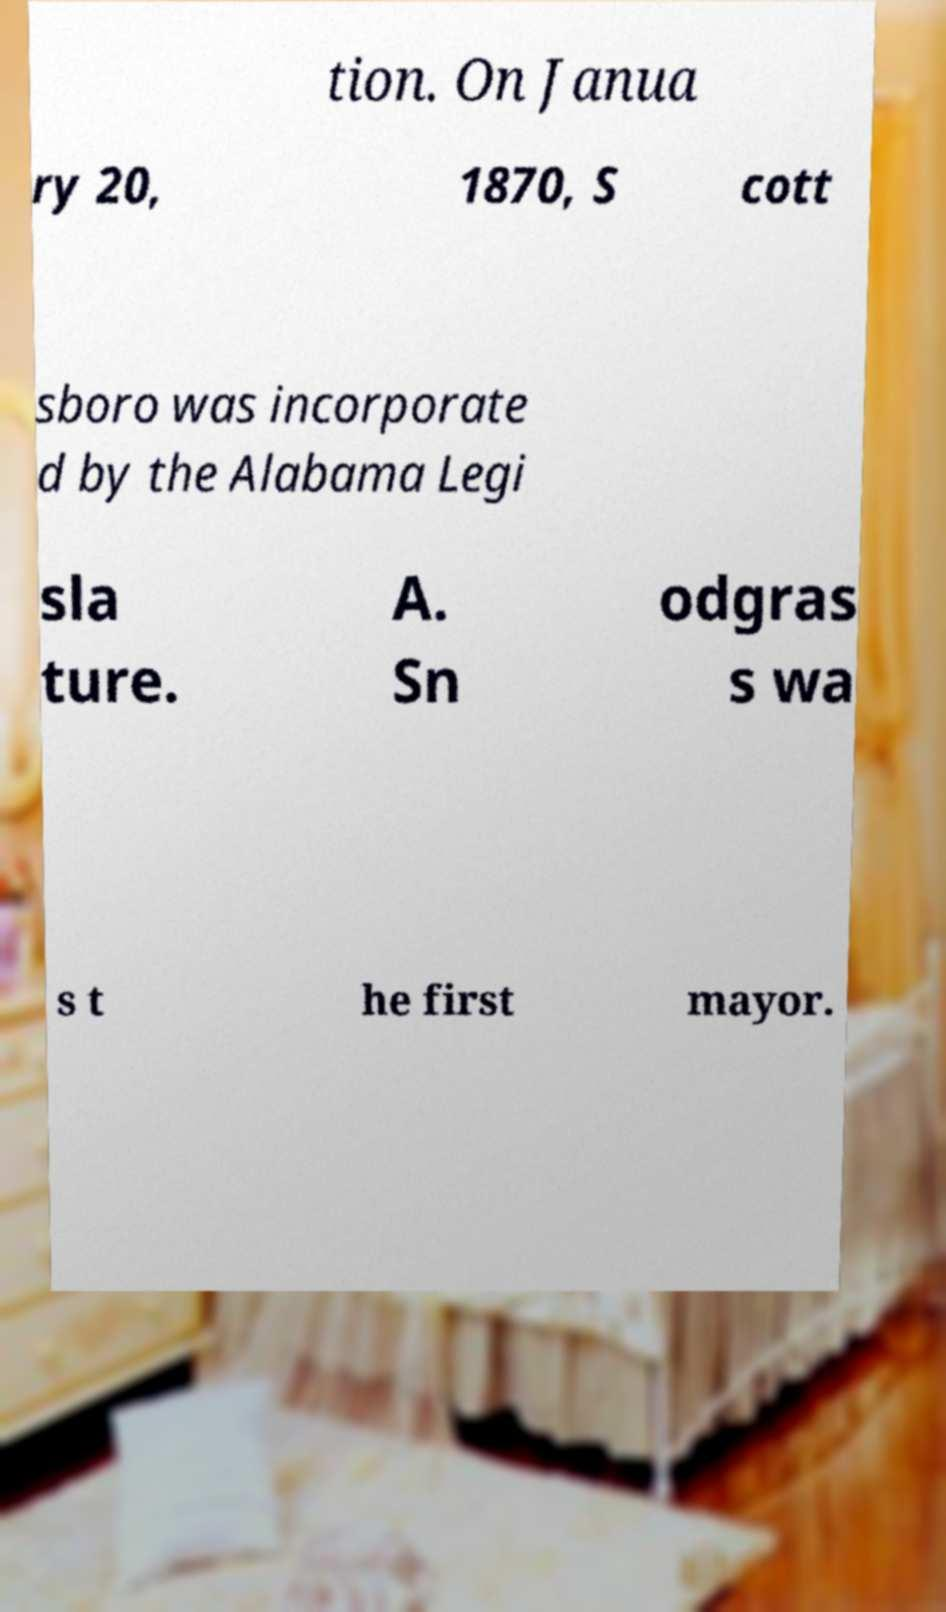What messages or text are displayed in this image? I need them in a readable, typed format. tion. On Janua ry 20, 1870, S cott sboro was incorporate d by the Alabama Legi sla ture. A. Sn odgras s wa s t he first mayor. 